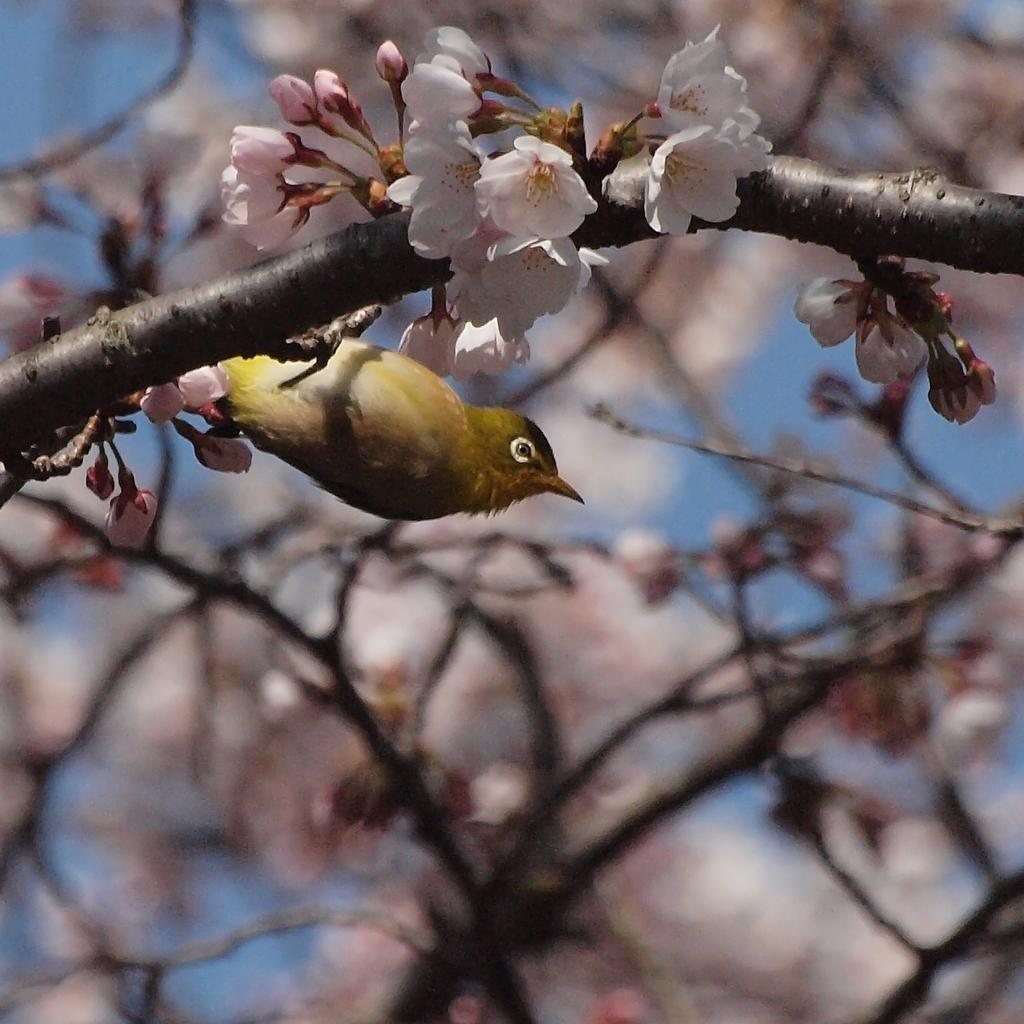What type of animal is present in the image? There is a bird in the image. What other elements can be seen in the image besides the bird? There are flowers and stems in the image. Can you describe the background of the image? The background of the image is blurred. What letters can be seen on the kitten in the bedroom in the image? There is no kitten or bedroom present in the image, and therefore no letters can be seen on a kitten in the bedroom. 